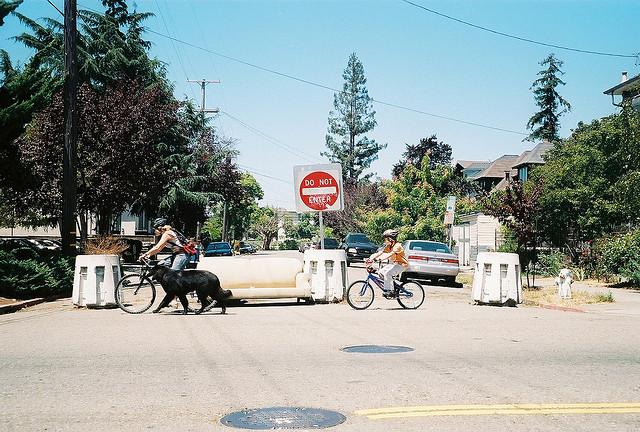Where is the dog?
Concise answer only. Street. What is the woman next to the van riding on?
Short answer required. Bike. What kind of animal do you see?
Quick response, please. Dog. Is the bike red?
Write a very short answer. No. How many bicycles are in the picture?
Keep it brief. 2. What time of day is it?
Answer briefly. Noon. What does the sign say?
Concise answer only. Do not enter. 